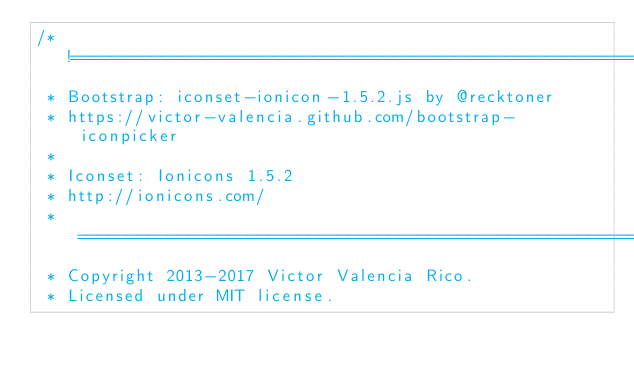Convert code to text. <code><loc_0><loc_0><loc_500><loc_500><_JavaScript_>/*!========================================================================
 * Bootstrap: iconset-ionicon-1.5.2.js by @recktoner
 * https://victor-valencia.github.com/bootstrap-iconpicker
 *
 * Iconset: Ionicons 1.5.2
 * http://ionicons.com/
 * ========================================================================
 * Copyright 2013-2017 Victor Valencia Rico.
 * Licensed under MIT license.</code> 